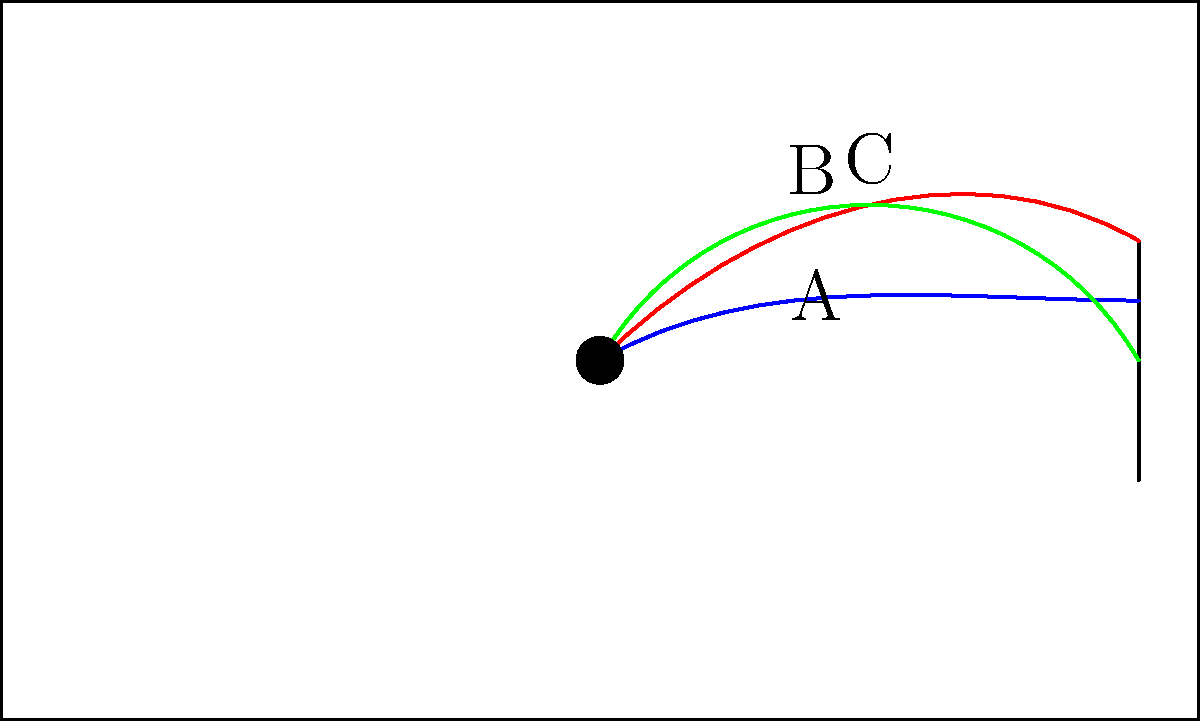As a die-hard sports fan with an eye for detail, analyze the diagram showing three different ball trajectories (A, B, and C) on a field. Which trajectory is most likely to result in a goal, assuming the ball maintains its path and the goal is regulation size? Let's analyze each trajectory step-by-step:

1. Trajectory A (blue):
   - Starts at a low angle (approximately 30 degrees)
   - Has a relatively flat arc
   - Ends at about mid-height of the goal post

2. Trajectory B (red):
   - Starts at a higher angle (approximately 45 degrees)
   - Has a more pronounced arc
   - Ends near the top of the goal post

3. Trajectory C (green):
   - Starts at the highest angle (approximately 60 degrees)
   - Has the most pronounced arc
   - Ends at the bottom of the goal post

Considering these factors:
- A regulation soccer goal is 8 feet (2.44 meters) high
- The goalkeeper can typically reach most of the goal area
- The most difficult shots to save are those that are low and near the corners

Based on this analysis, Trajectory A is most likely to result in a goal because:
1. It has a flatter trajectory, making it harder for the goalkeeper to predict
2. It ends at about mid-height, which is a challenging height for goalkeepers
3. It maintains a good balance between speed and accuracy

Trajectory B is too high and might go over the crossbar, while Trajectory C drops too sharply and might be easier for the goalkeeper to save or miss the goal entirely.
Answer: Trajectory A 